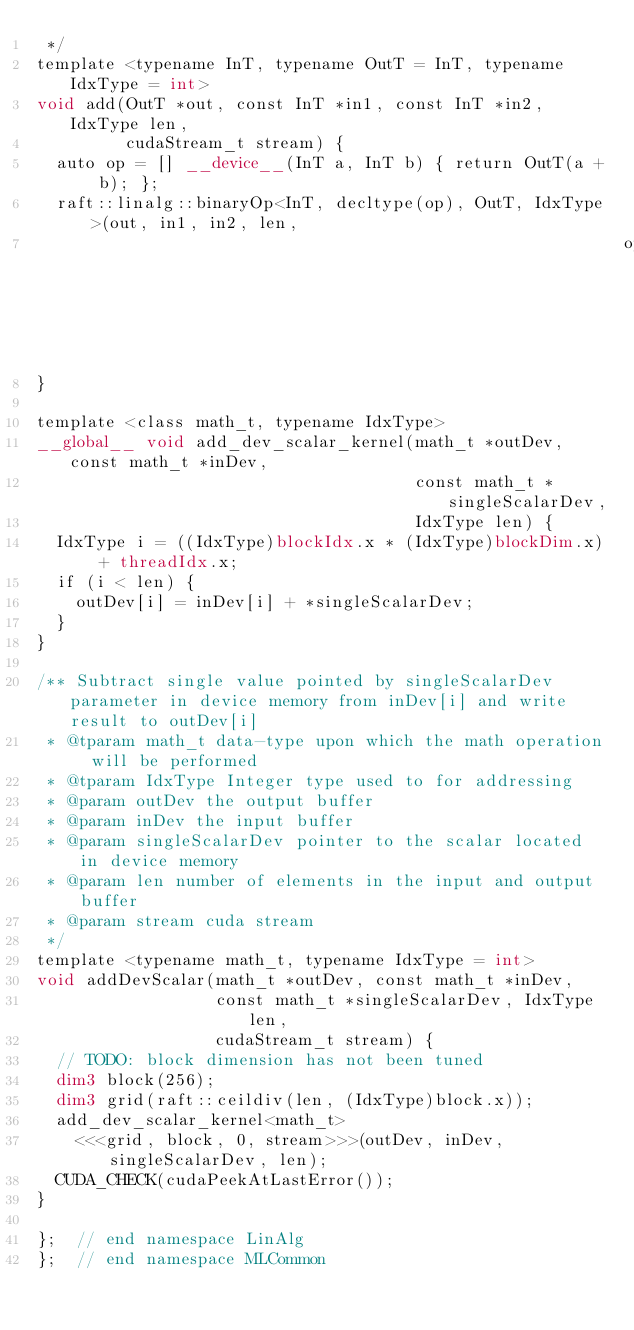Convert code to text. <code><loc_0><loc_0><loc_500><loc_500><_Cuda_> */
template <typename InT, typename OutT = InT, typename IdxType = int>
void add(OutT *out, const InT *in1, const InT *in2, IdxType len,
         cudaStream_t stream) {
  auto op = [] __device__(InT a, InT b) { return OutT(a + b); };
  raft::linalg::binaryOp<InT, decltype(op), OutT, IdxType>(out, in1, in2, len,
                                                           op, stream);
}

template <class math_t, typename IdxType>
__global__ void add_dev_scalar_kernel(math_t *outDev, const math_t *inDev,
                                      const math_t *singleScalarDev,
                                      IdxType len) {
  IdxType i = ((IdxType)blockIdx.x * (IdxType)blockDim.x) + threadIdx.x;
  if (i < len) {
    outDev[i] = inDev[i] + *singleScalarDev;
  }
}

/** Subtract single value pointed by singleScalarDev parameter in device memory from inDev[i] and write result to outDev[i]
 * @tparam math_t data-type upon which the math operation will be performed
 * @tparam IdxType Integer type used to for addressing
 * @param outDev the output buffer
 * @param inDev the input buffer
 * @param singleScalarDev pointer to the scalar located in device memory
 * @param len number of elements in the input and output buffer
 * @param stream cuda stream
 */
template <typename math_t, typename IdxType = int>
void addDevScalar(math_t *outDev, const math_t *inDev,
                  const math_t *singleScalarDev, IdxType len,
                  cudaStream_t stream) {
  // TODO: block dimension has not been tuned
  dim3 block(256);
  dim3 grid(raft::ceildiv(len, (IdxType)block.x));
  add_dev_scalar_kernel<math_t>
    <<<grid, block, 0, stream>>>(outDev, inDev, singleScalarDev, len);
  CUDA_CHECK(cudaPeekAtLastError());
}

};  // end namespace LinAlg
};  // end namespace MLCommon
</code> 